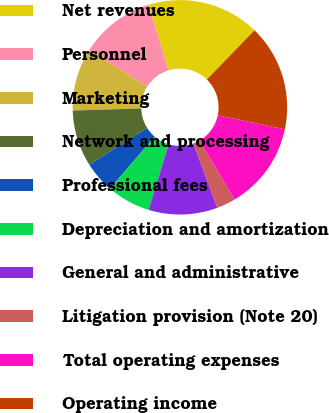Convert chart to OTSL. <chart><loc_0><loc_0><loc_500><loc_500><pie_chart><fcel>Net revenues<fcel>Personnel<fcel>Marketing<fcel>Network and processing<fcel>Professional fees<fcel>Depreciation and amortization<fcel>General and administrative<fcel>Litigation provision (Note 20)<fcel>Total operating expenses<fcel>Operating income<nl><fcel>16.98%<fcel>11.32%<fcel>9.43%<fcel>8.49%<fcel>4.72%<fcel>6.6%<fcel>10.38%<fcel>2.83%<fcel>13.21%<fcel>16.04%<nl></chart> 